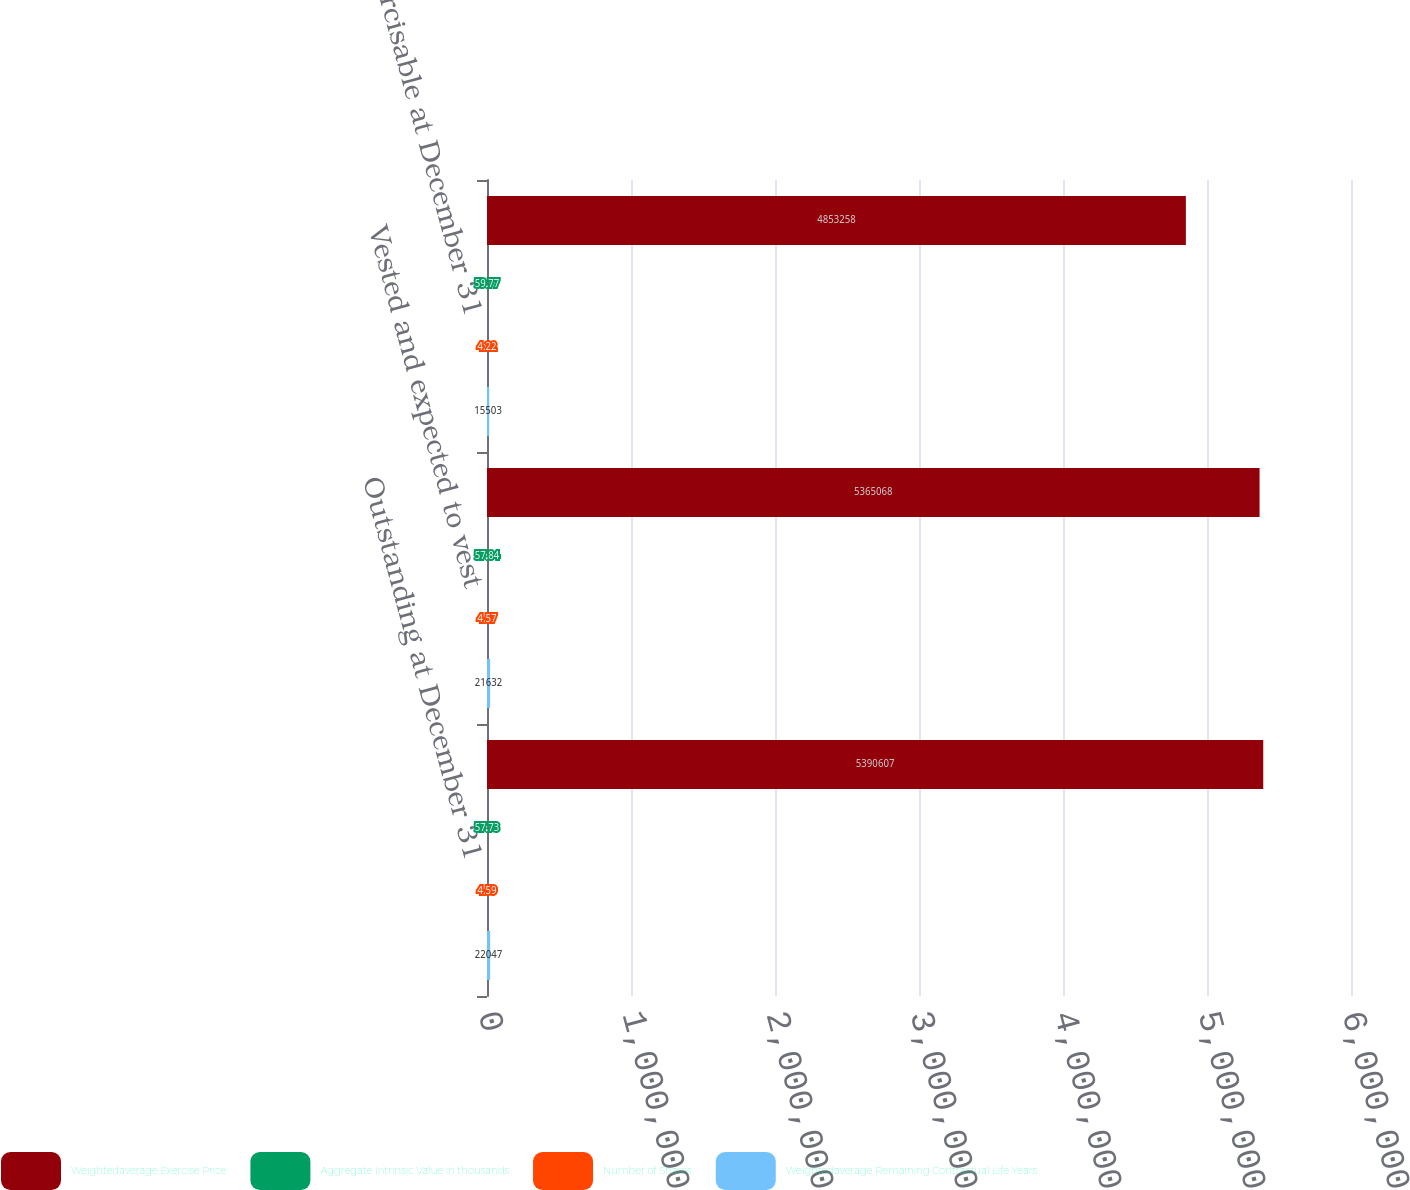Convert chart to OTSL. <chart><loc_0><loc_0><loc_500><loc_500><stacked_bar_chart><ecel><fcel>Outstanding at December 31<fcel>Vested and expected to vest<fcel>Exercisable at December 31<nl><fcel>Weightedaverage Exercise Price<fcel>5.39061e+06<fcel>5.36507e+06<fcel>4.85326e+06<nl><fcel>Aggregate Intrinsic Value in thousands<fcel>57.73<fcel>57.84<fcel>59.77<nl><fcel>Number of Shares<fcel>4.59<fcel>4.57<fcel>4.22<nl><fcel>Weightedaverage Remaining Contractual Life Years<fcel>22047<fcel>21632<fcel>15503<nl></chart> 